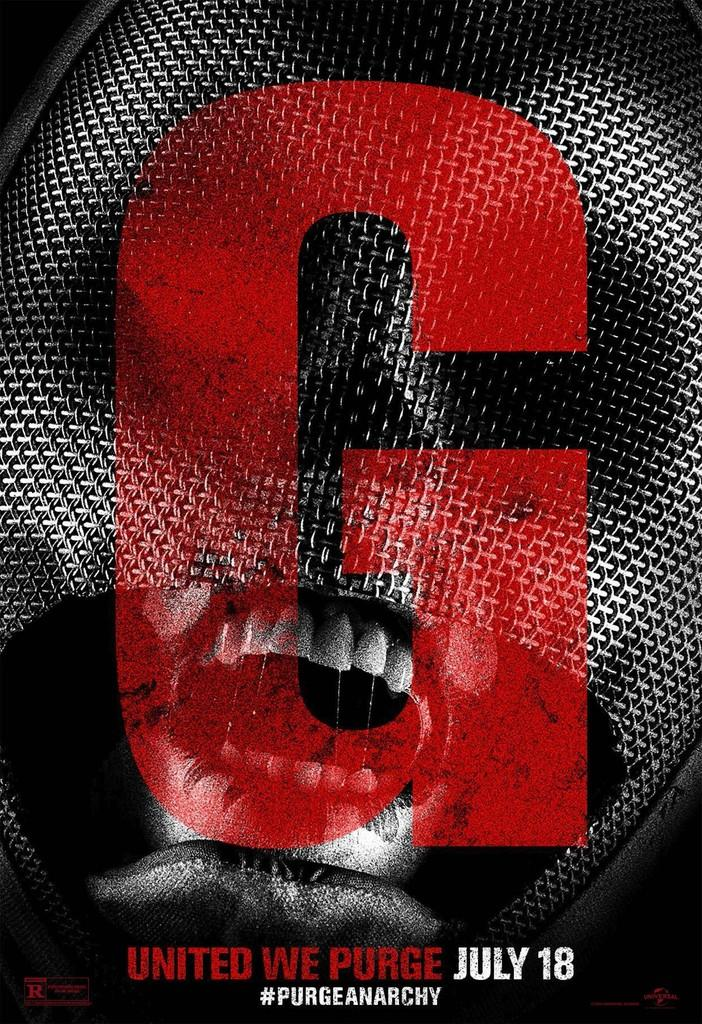<image>
Write a terse but informative summary of the picture. a black and white photo for the movie the purge 